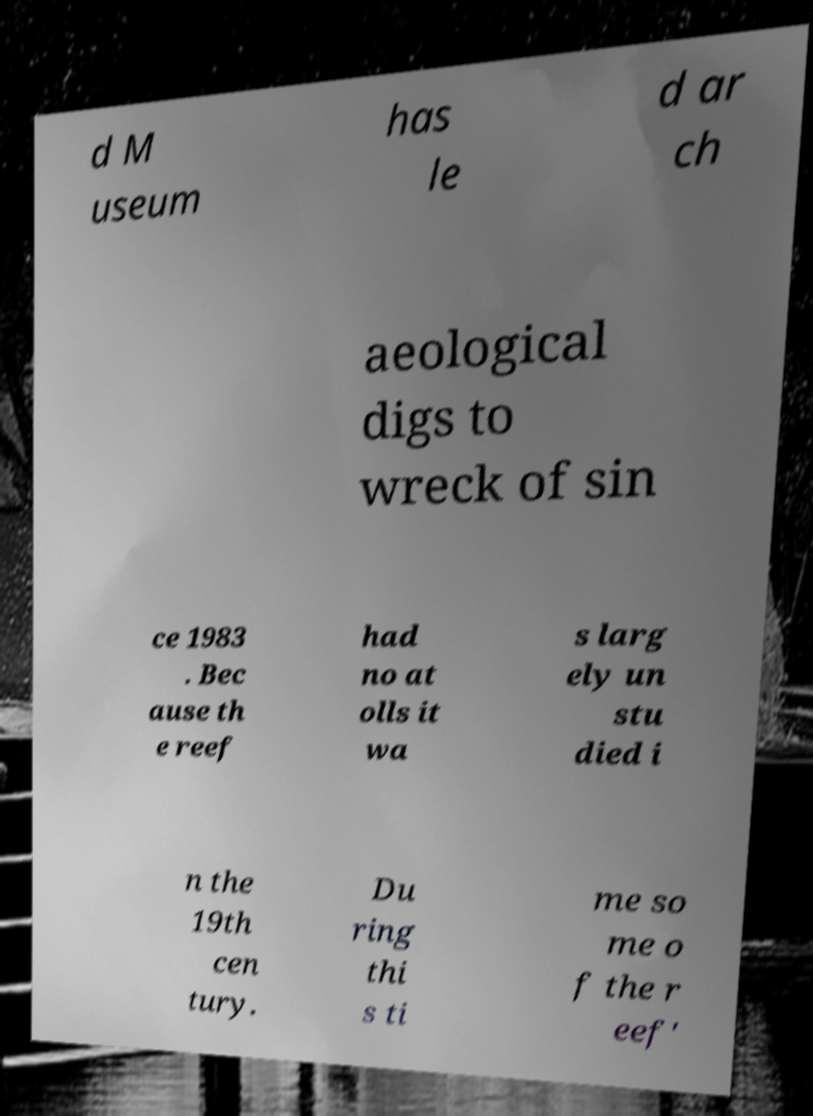Please identify and transcribe the text found in this image. d M useum has le d ar ch aeological digs to wreck of sin ce 1983 . Bec ause th e reef had no at olls it wa s larg ely un stu died i n the 19th cen tury. Du ring thi s ti me so me o f the r eef' 